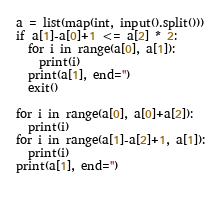Convert code to text. <code><loc_0><loc_0><loc_500><loc_500><_Python_>a = list(map(int, input().split()))
if a[1]-a[0]+1 <= a[2] * 2:
  for i in range(a[0], a[1]):
    print(i)
  print(a[1], end='')
  exit()

for i in range(a[0], a[0]+a[2]):
  print(i)
for i in range(a[1]-a[2]+1, a[1]):
  print(i)
print(a[1], end='')
  </code> 